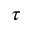<formula> <loc_0><loc_0><loc_500><loc_500>\tau</formula> 